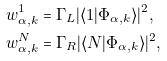<formula> <loc_0><loc_0><loc_500><loc_500>w _ { \alpha , k } ^ { 1 } & = \Gamma _ { L } | \langle 1 | \Phi _ { \alpha , k } \rangle | ^ { 2 } , \\ w _ { \alpha , k } ^ { N } & = \Gamma _ { R } | \langle N | \Phi _ { \alpha , k } \rangle | ^ { 2 } ,</formula> 